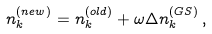<formula> <loc_0><loc_0><loc_500><loc_500>n _ { k } ^ { ( n e w ) } = n _ { k } ^ { ( o l d ) } + \omega \Delta n _ { k } ^ { ( G S ) } \, ,</formula> 